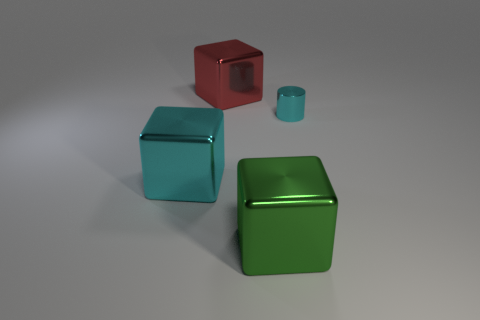Add 4 purple balls. How many objects exist? 8 Subtract all blocks. How many objects are left? 1 Subtract 0 yellow spheres. How many objects are left? 4 Subtract 1 cylinders. How many cylinders are left? 0 Subtract all red cylinders. Subtract all green balls. How many cylinders are left? 1 Subtract all green shiny things. Subtract all small cyan cylinders. How many objects are left? 2 Add 2 large cyan metal things. How many large cyan metal things are left? 3 Add 1 red objects. How many red objects exist? 2 